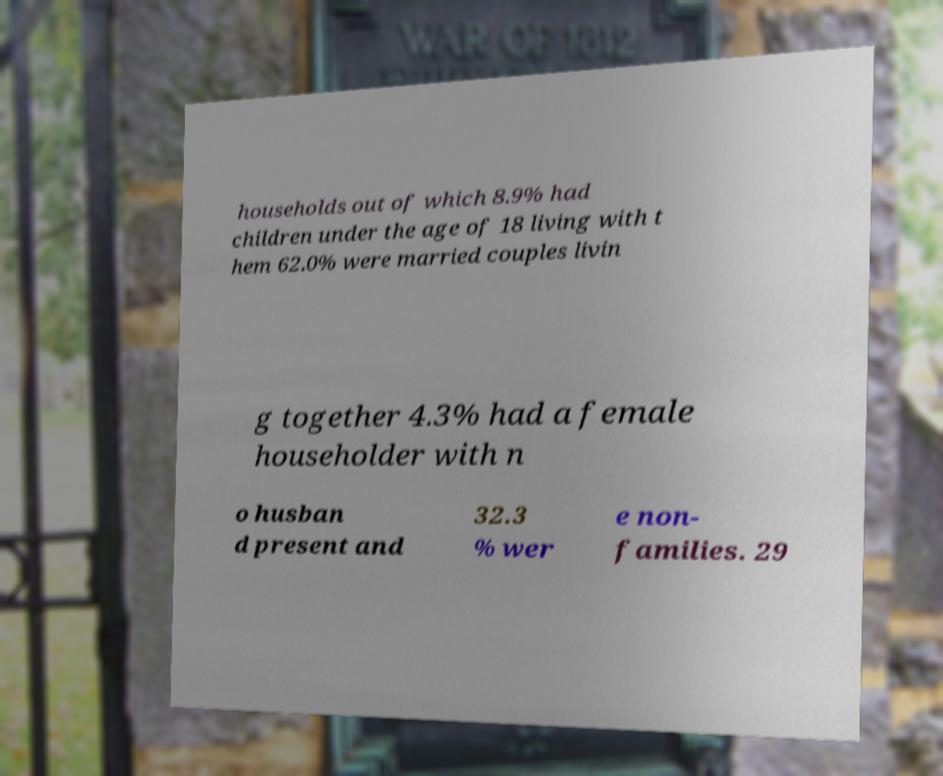Can you accurately transcribe the text from the provided image for me? households out of which 8.9% had children under the age of 18 living with t hem 62.0% were married couples livin g together 4.3% had a female householder with n o husban d present and 32.3 % wer e non- families. 29 